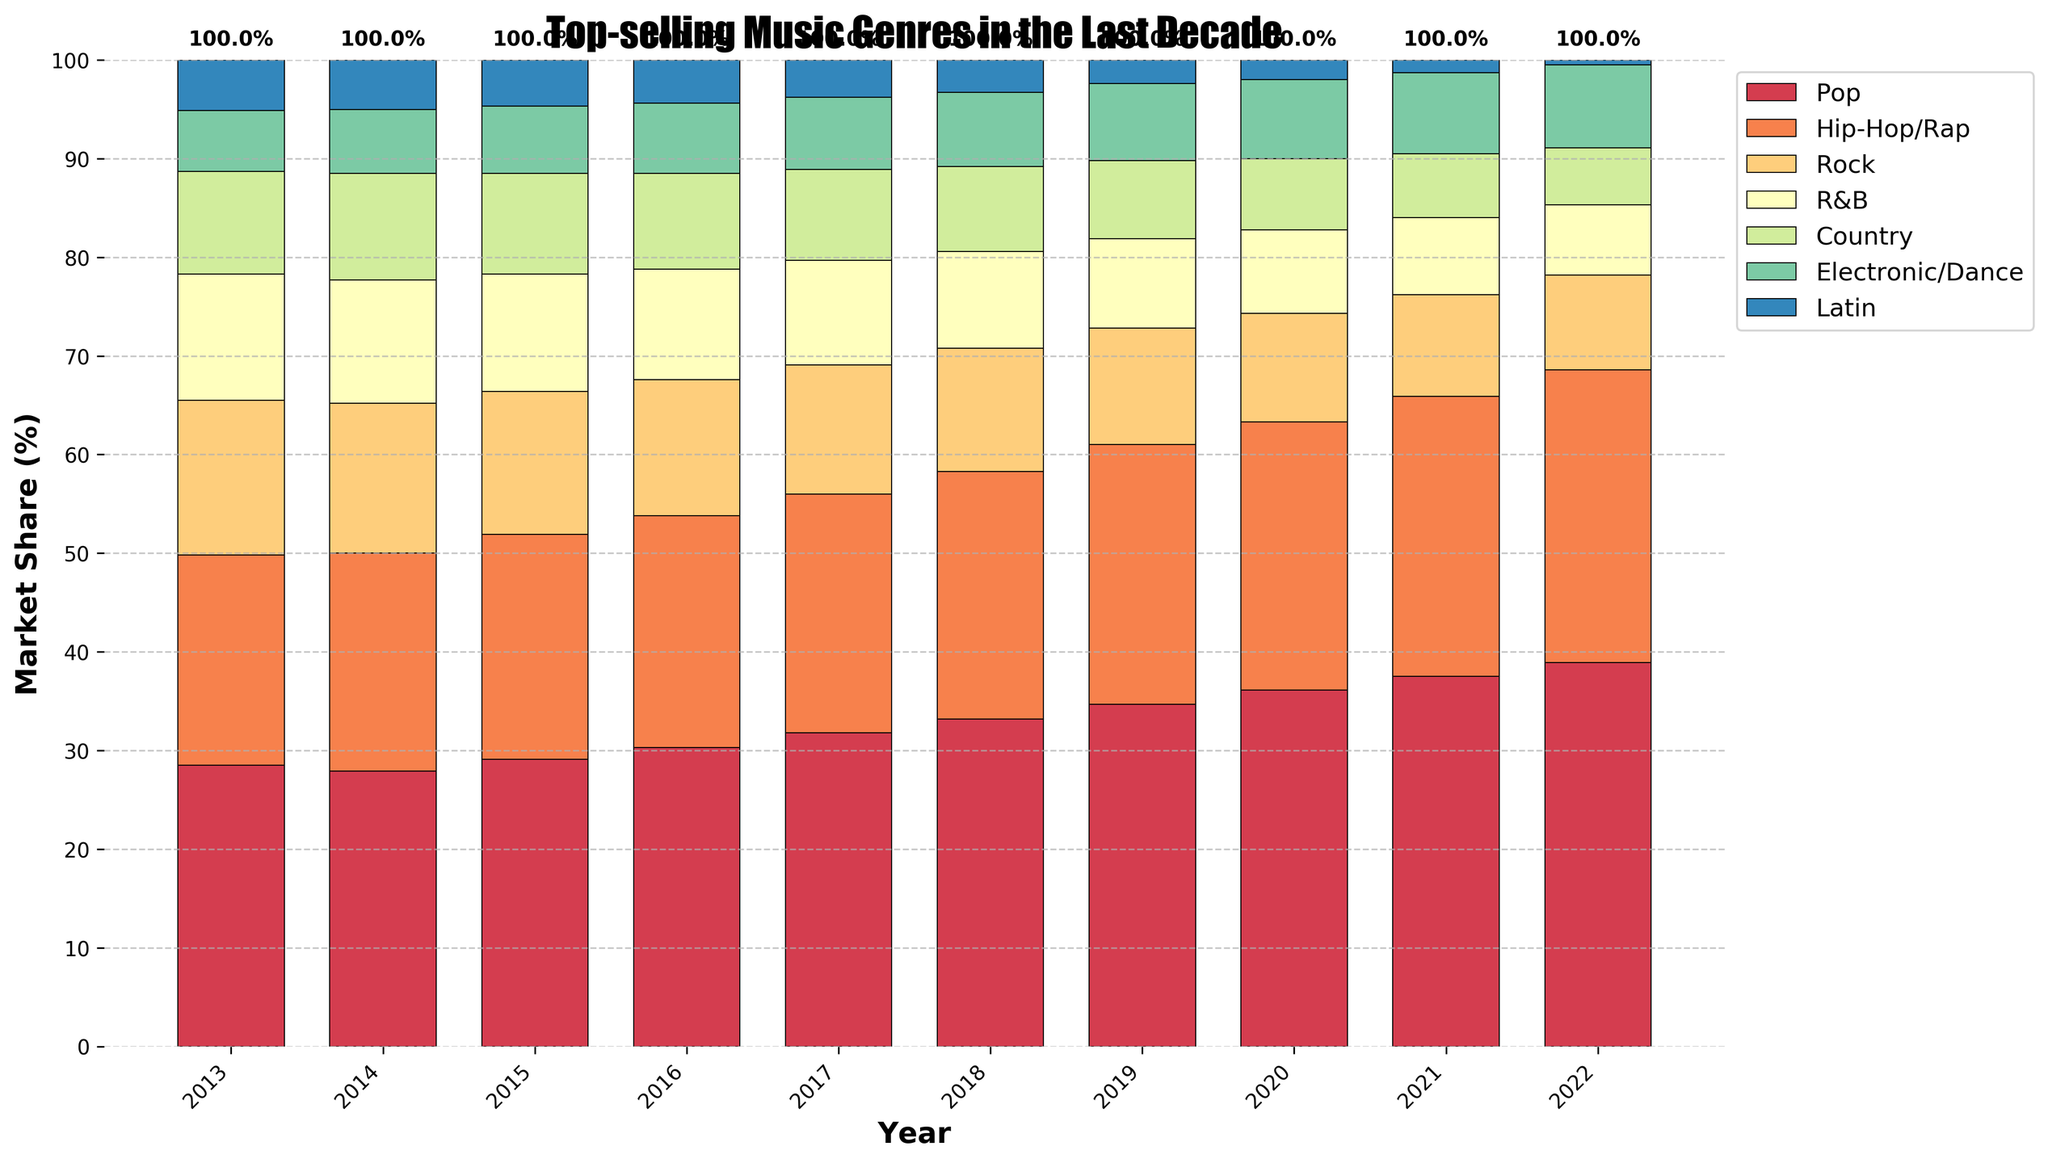What's the dominant genre in 2022? The highest bar in 2022 represents the dominant genre. In 2022, the bar corresponding to Pop is the highest.
Answer: Pop Which genre had the most consistent percentage over the decade? By looking at the heights of the bars for each genre over the years, the genre with fairly even bars indicates consistency. The Electronic/Dance genre shows minimal fluctuation.
Answer: Electronic/Dance How did the market share of Hip-Hop/Rap change from 2013 to 2022? Subtract the market share of Hip-Hop/Rap in 2013 from its share in 2022. 29.7% - 21.3% = 8.4%.
Answer: Increased by 8.4% In which year did the Rock genre first fall below 12% market share? Identify the first year where the Rock bar height is below the 12% mark. This occurs first in 2018 at 12.5%, as 2019 has 11.8%.
Answer: 2019 What was the combined market share of Pop and Country in 2013? Sum the market shares of Pop and Country in 2013. 28.5% + 10.4% = 38.9%.
Answer: 38.9% Which year had the highest total market share percentage for R&B and Latin genres? Calculate the combined market shares of R&B and Latin for each year and identify the highest. 2013: 12.8% + 5.1% = 17.9%, and so forth. The highest is in 2013.
Answer: 2013 What trend can you observe about the popularity of the Pop genre over the decade? Examine the height of the Pop bars from 2013 to 2022. The bars consistently increase in height, indicating a rise in popularity.
Answer: Increasing trend Compare the market share of R&B and Hip-Hop/Rap in 2021. Which one was higher and by how much? Subtract the market share of R&B in 2021 from Hip-Hop/Rap in 2021. 28.4% - 7.8% = 20.6%.
Answer: Hip-Hop/Rap by 20.6% What is the average market share of the Country genre over the decade? Sum the market shares of the Country genre from 2013 to 2022 and divide by the number of years. (10.4% + 10.8% + 10.2% + 9.7% + 9.2% + 8.6% + 7.9% + 7.2% + 6.5% + 5.8%) / 10 = 8.63%.
Answer: 8.63% Identify the year when Electronic/Dance saw its highest market share. Find the year with the tallest bar for Electronic/Dance. The highest bar is in 2022 with 8.4%.
Answer: 2022 